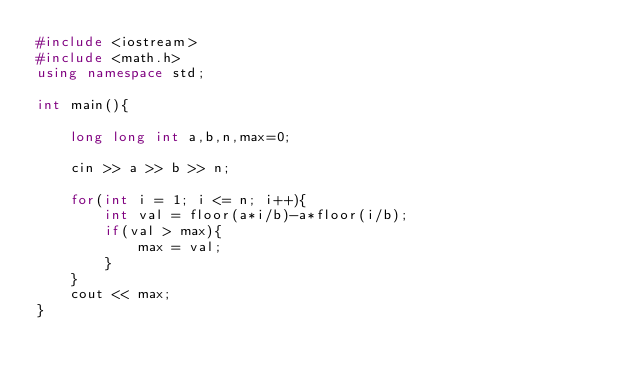Convert code to text. <code><loc_0><loc_0><loc_500><loc_500><_C++_>#include <iostream>
#include <math.h>
using namespace std;

int main(){

	long long int a,b,n,max=0;
    
    cin >> a >> b >> n;
    
    for(int i = 1; i <= n; i++){
		int val = floor(a*i/b)-a*floor(i/b);
        if(val > max){
        	max = val;
        }
    }
    cout << max;
}</code> 